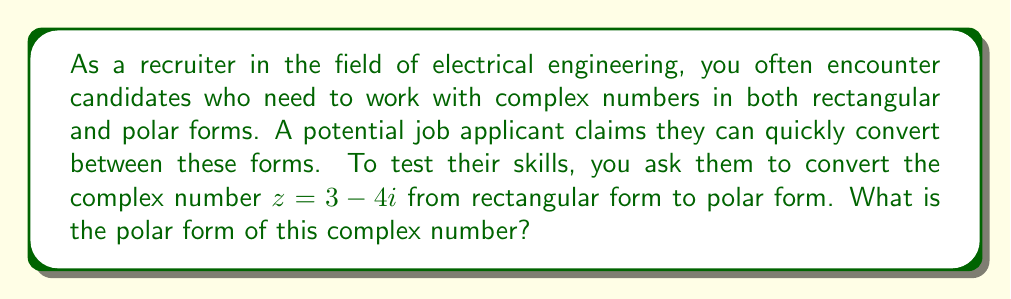Provide a solution to this math problem. To convert a complex number from rectangular form $(a + bi)$ to polar form $(r \angle \theta)$, we need to follow these steps:

1. Calculate the modulus $r$:
   $r = \sqrt{a^2 + b^2}$
   Here, $r = \sqrt{3^2 + (-4)^2} = \sqrt{9 + 16} = \sqrt{25} = 5$

2. Calculate the argument $\theta$:
   $\theta = \arctan(\frac{b}{a})$
   However, we need to be careful with the quadrant. Since $a$ is positive and $b$ is negative, we're in the fourth quadrant.
   
   $\theta = \arctan(\frac{-4}{3}) \approx -0.9273$ radians
   
   To get the angle in the correct quadrant, we add $2\pi$ to this value:
   $\theta \approx -0.9273 + 2\pi \approx 5.3558$ radians

3. Express the complex number in polar form:
   $z = r(\cos\theta + i\sin\theta) = 5(\cos 5.3558 + i\sin 5.3558)$

Alternatively, we can express this in the more compact form:
$z = 5 \angle 5.3558$

Note: The angle can also be expressed in degrees as approximately 306.87°.
Answer: $5 \angle 5.3558$ radians or $5 \angle 306.87°$ 